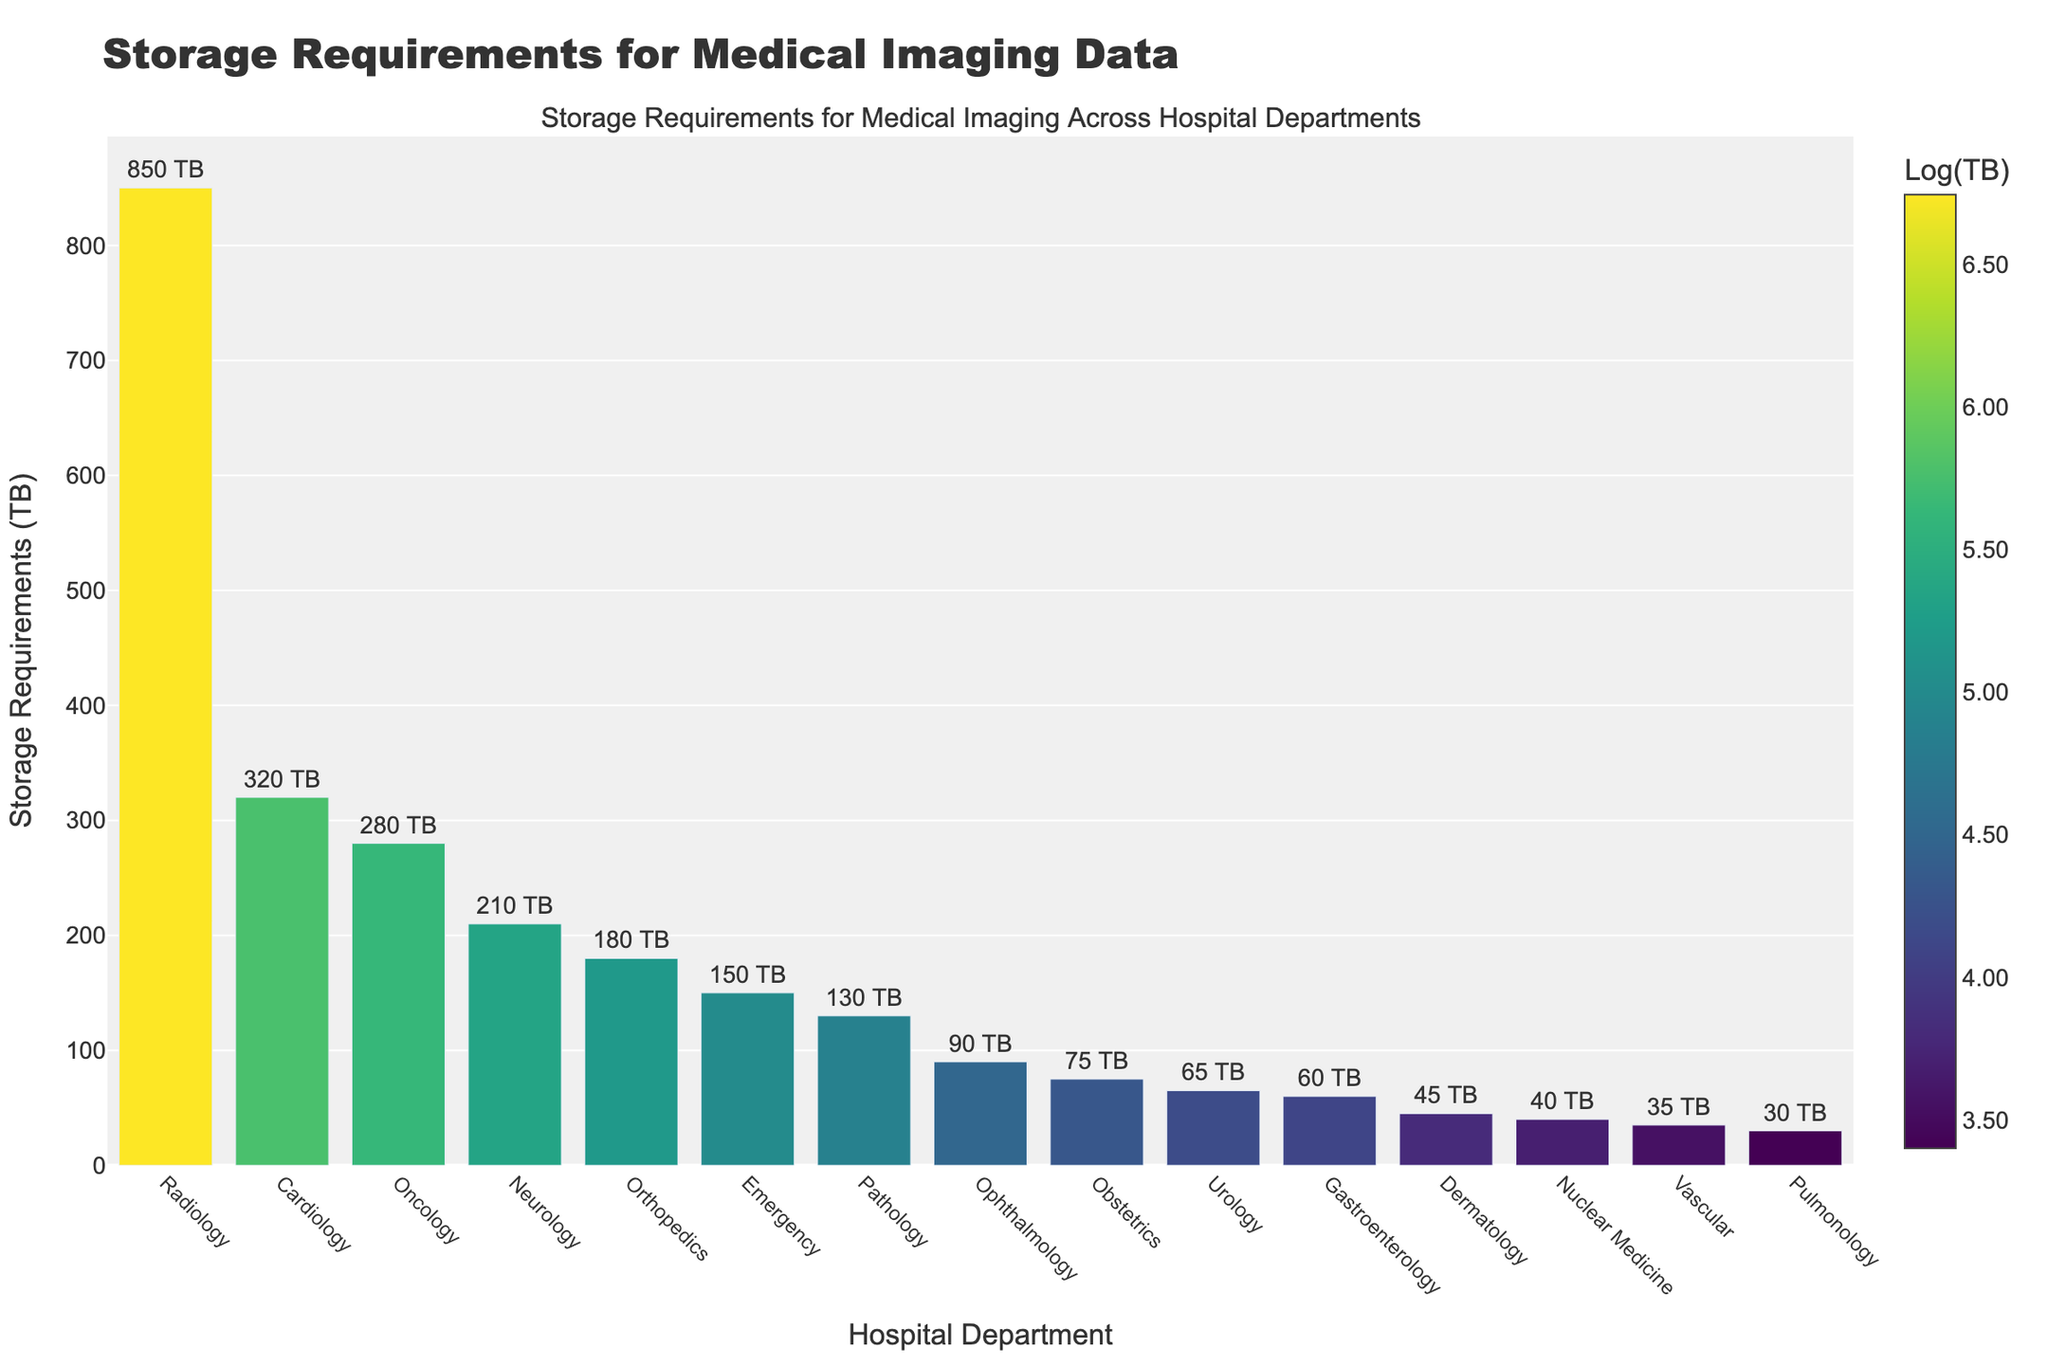Which department has the highest storage requirement? By examining the height of the bars, we see that the Radiology department has the tallest bar, indicating the highest storage requirement.
Answer: Radiology Which department has the lowest storage requirement? Observing the shortest bar in the chart, we can see that the Pulmonology department has the smallest height, indicating the lowest storage requirement.
Answer: Pulmonology How much more storage is required by Radiology compared to Cardiology? The storage requirements for Radiology and Cardiology are 850 TB and 320 TB respectively. Subtracting these values, Radiology requires 850 - 320 = 530 TB more than Cardiology.
Answer: 530 TB What is the total storage requirement for the top three departments? The top three departments in terms of storage requirements are Radiology (850 TB), Cardiology (320 TB), and Oncology (280 TB). Summing these values, the total storage requirement is 850 + 320 + 280 = 1450 TB.
Answer: 1450 TB Which department has exactly half the storage requirement of Oncology? Oncology has a storage requirement of 280 TB. Half of this amount is 280 / 2 = 140 TB. Examining the bars, none of the departments have exactly 140 TB, but Pathology is closest with 130 TB.
Answer: None (closest is Pathology) Are there more departments with storage requirements above 100 TB or below 100 TB? Counting the departments with storage requirements above 100 TB: Radiology, Cardiology, Oncology, Neurology, Orthopedics, Emergency, Pathology, there are 7. Counting departments below 100 TB: Ophthalmology, Obstetrics, Urology, Gastroenterology, Dermatology, Nuclear Medicine, Vascular, Pulmonology, there are 8.
Answer: Below 100 TB Which department has a storage requirement closest to the average storage requirement of all departments? Summing all storage requirements and dividing by the number of departments gives the average: (850+320+280+210+180+150+130+90+75+65+60+45+40+35+30)/15 = 176.67 TB. The department closest to 176.67 TB is Orthopedics with 180 TB.
Answer: Orthopedics How many departments have storage requirements that are less than the average storage requirement? The average storage requirement is 176.67 TB. Departments with storage below this value are: Pathology, Ophthalmology, Obstetrics, Urology, Gastroenterology, Dermatology, Nuclear Medicine, Vascular, Pulmonology (9 departments).
Answer: 9 